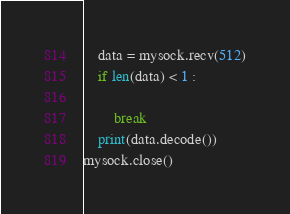<code> <loc_0><loc_0><loc_500><loc_500><_Python_>    data = mysock.recv(512)
    if len(data) < 1 :
        
        break
    print(data.decode())
mysock.close()</code> 